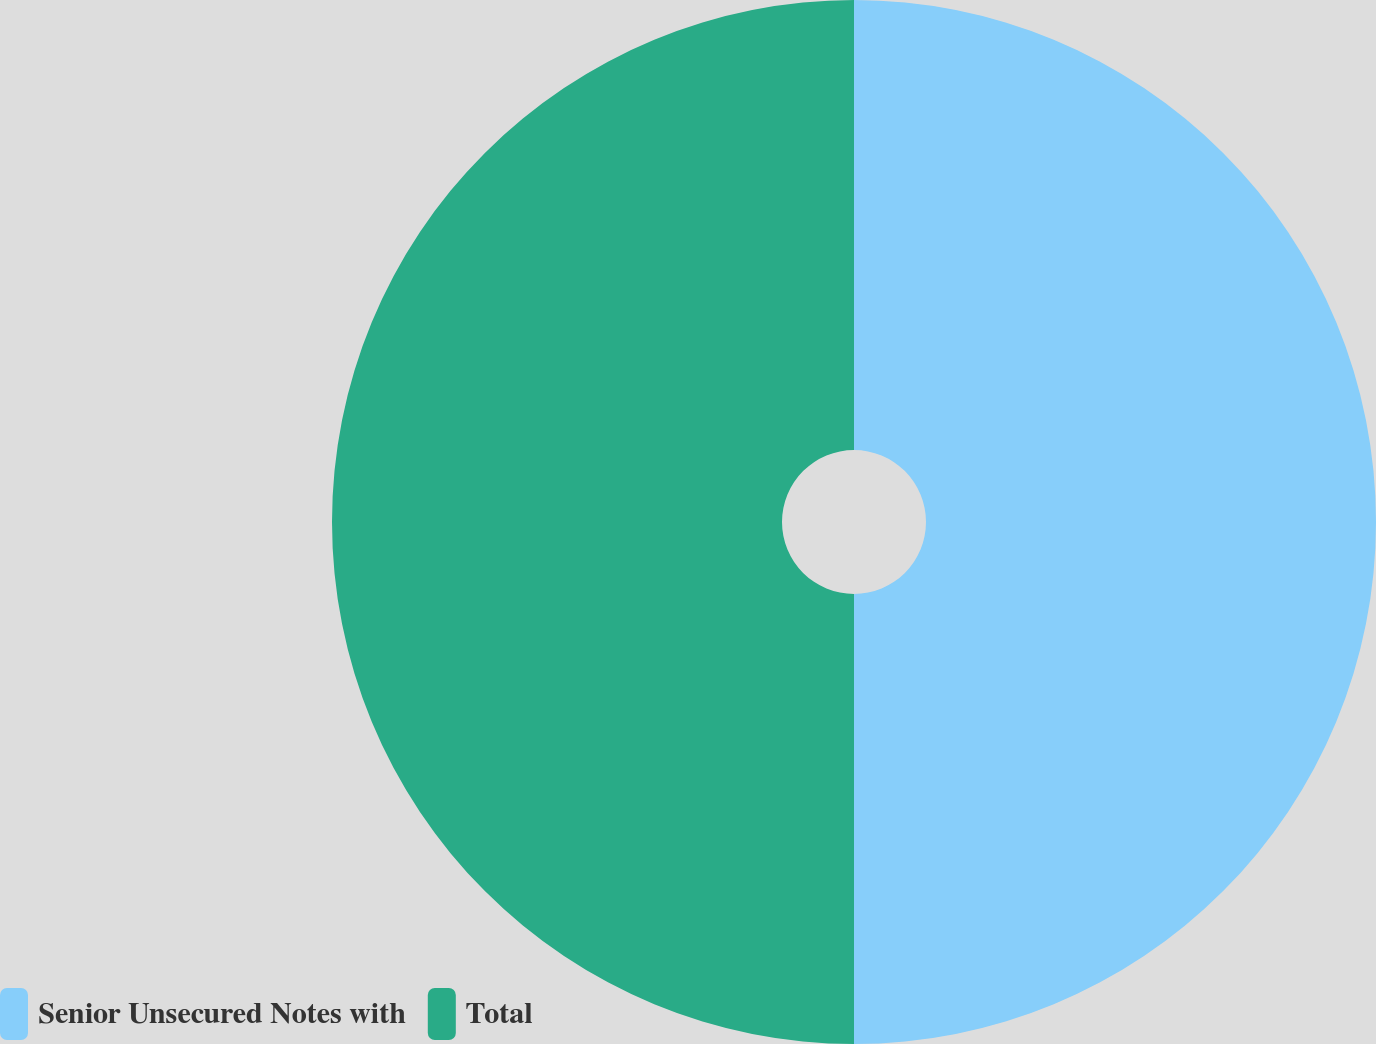<chart> <loc_0><loc_0><loc_500><loc_500><pie_chart><fcel>Senior Unsecured Notes with<fcel>Total<nl><fcel>50.0%<fcel>50.0%<nl></chart> 